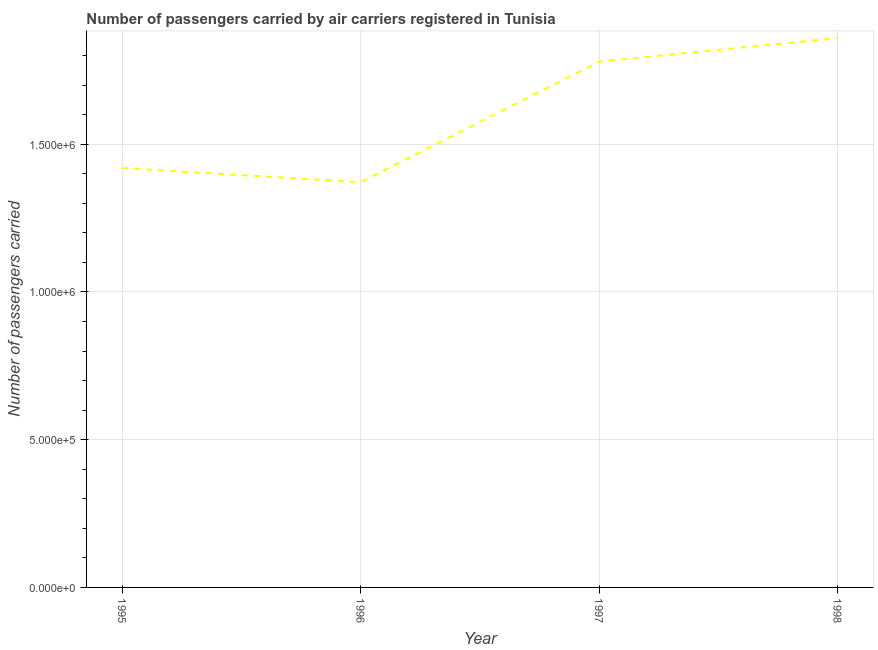What is the number of passengers carried in 1997?
Your response must be concise. 1.78e+06. Across all years, what is the maximum number of passengers carried?
Ensure brevity in your answer.  1.86e+06. Across all years, what is the minimum number of passengers carried?
Provide a succinct answer. 1.37e+06. In which year was the number of passengers carried minimum?
Your answer should be compact. 1996. What is the sum of the number of passengers carried?
Offer a terse response. 6.43e+06. What is the difference between the number of passengers carried in 1995 and 1998?
Provide a short and direct response. -4.40e+05. What is the average number of passengers carried per year?
Offer a terse response. 1.61e+06. What is the median number of passengers carried?
Your response must be concise. 1.60e+06. In how many years, is the number of passengers carried greater than 1300000 ?
Offer a terse response. 4. Do a majority of the years between 1998 and 1996 (inclusive) have number of passengers carried greater than 100000 ?
Ensure brevity in your answer.  No. What is the ratio of the number of passengers carried in 1996 to that in 1997?
Give a very brief answer. 0.77. Is the difference between the number of passengers carried in 1996 and 1997 greater than the difference between any two years?
Your response must be concise. No. What is the difference between the highest and the second highest number of passengers carried?
Give a very brief answer. 7.97e+04. What is the difference between the highest and the lowest number of passengers carried?
Provide a succinct answer. 4.88e+05. In how many years, is the number of passengers carried greater than the average number of passengers carried taken over all years?
Ensure brevity in your answer.  2. Does the number of passengers carried monotonically increase over the years?
Ensure brevity in your answer.  No. Does the graph contain any zero values?
Provide a succinct answer. No. Does the graph contain grids?
Offer a very short reply. Yes. What is the title of the graph?
Offer a terse response. Number of passengers carried by air carriers registered in Tunisia. What is the label or title of the Y-axis?
Offer a very short reply. Number of passengers carried. What is the Number of passengers carried of 1995?
Give a very brief answer. 1.42e+06. What is the Number of passengers carried of 1996?
Provide a short and direct response. 1.37e+06. What is the Number of passengers carried of 1997?
Offer a very short reply. 1.78e+06. What is the Number of passengers carried of 1998?
Ensure brevity in your answer.  1.86e+06. What is the difference between the Number of passengers carried in 1995 and 1996?
Provide a succinct answer. 4.82e+04. What is the difference between the Number of passengers carried in 1995 and 1997?
Keep it short and to the point. -3.60e+05. What is the difference between the Number of passengers carried in 1995 and 1998?
Offer a very short reply. -4.40e+05. What is the difference between the Number of passengers carried in 1996 and 1997?
Your response must be concise. -4.08e+05. What is the difference between the Number of passengers carried in 1996 and 1998?
Give a very brief answer. -4.88e+05. What is the difference between the Number of passengers carried in 1997 and 1998?
Your response must be concise. -7.97e+04. What is the ratio of the Number of passengers carried in 1995 to that in 1996?
Your answer should be very brief. 1.03. What is the ratio of the Number of passengers carried in 1995 to that in 1997?
Provide a short and direct response. 0.8. What is the ratio of the Number of passengers carried in 1995 to that in 1998?
Your answer should be compact. 0.76. What is the ratio of the Number of passengers carried in 1996 to that in 1997?
Offer a terse response. 0.77. What is the ratio of the Number of passengers carried in 1996 to that in 1998?
Offer a terse response. 0.74. 